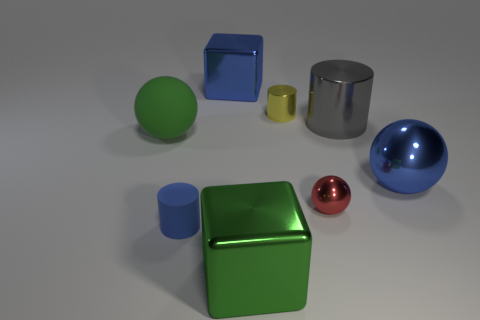Are there any objects in the image that have the same shape? Yes, there are objects with the same shape. The large green cube and the smaller blue cube share the same cubic shape, just different sizes and colors. And what about the spheres? Similarly, there are two spheres in the image: one large blue metallic ball and one small red metallic ball. They have the same spherical shape but are different in size and color. 